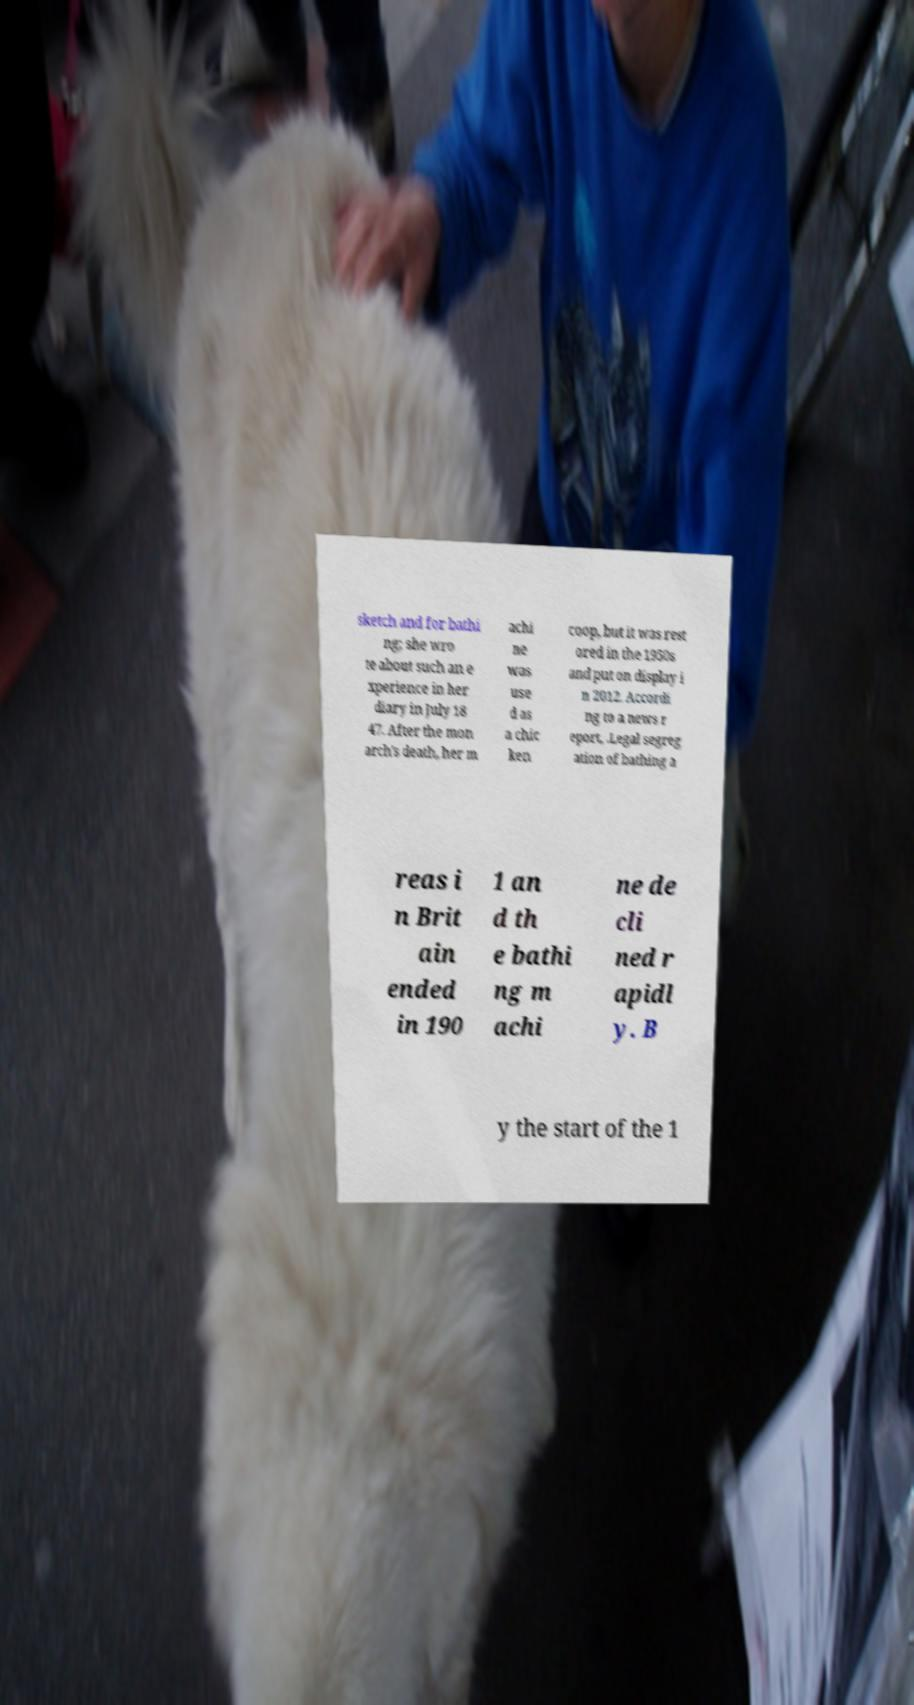For documentation purposes, I need the text within this image transcribed. Could you provide that? sketch and for bathi ng; she wro te about such an e xperience in her diary in July 18 47. After the mon arch's death, her m achi ne was use d as a chic ken coop, but it was rest ored in the 1950s and put on display i n 2012. Accordi ng to a news r eport, .Legal segreg ation of bathing a reas i n Brit ain ended in 190 1 an d th e bathi ng m achi ne de cli ned r apidl y. B y the start of the 1 